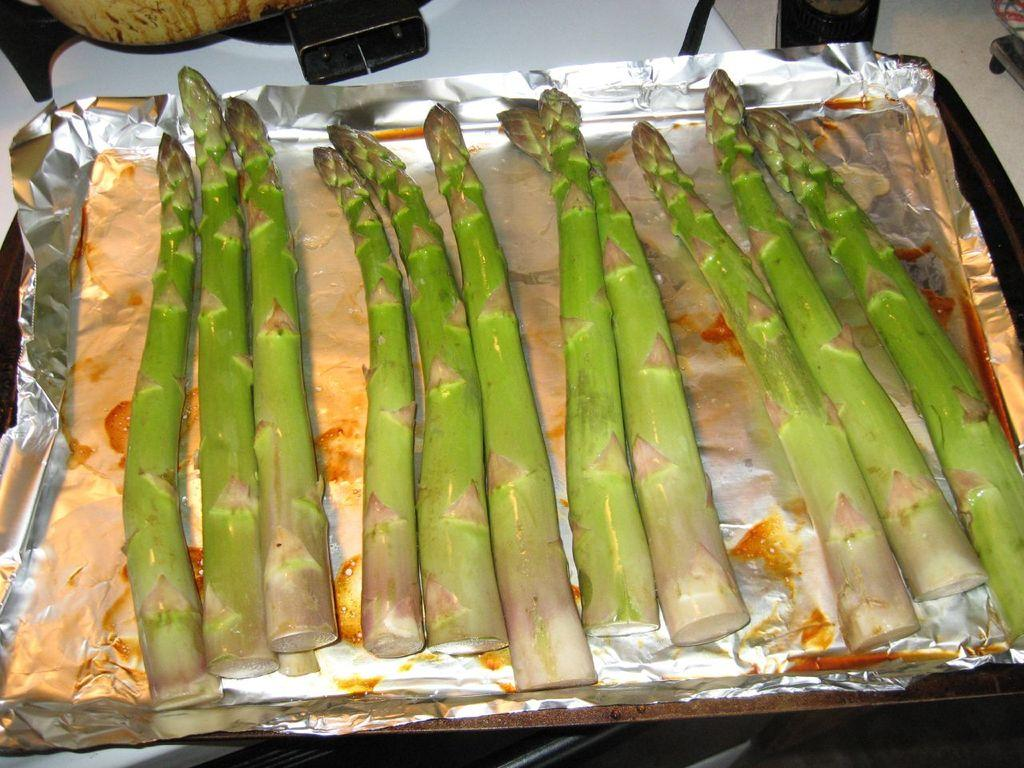What type of vegetable is present in the image? There is asparagus in the image. How is the asparagus being stored or presented? The asparagus is on a silver foil. What is the silver foil placed on? The silver foil is on a tray. What can be seen at the top of the image? There are objects visible at the top of the image. What type of fuel is being used to cook the asparagus in the image? There is no indication in the image that the asparagus is being cooked, nor is there any mention of fuel. 